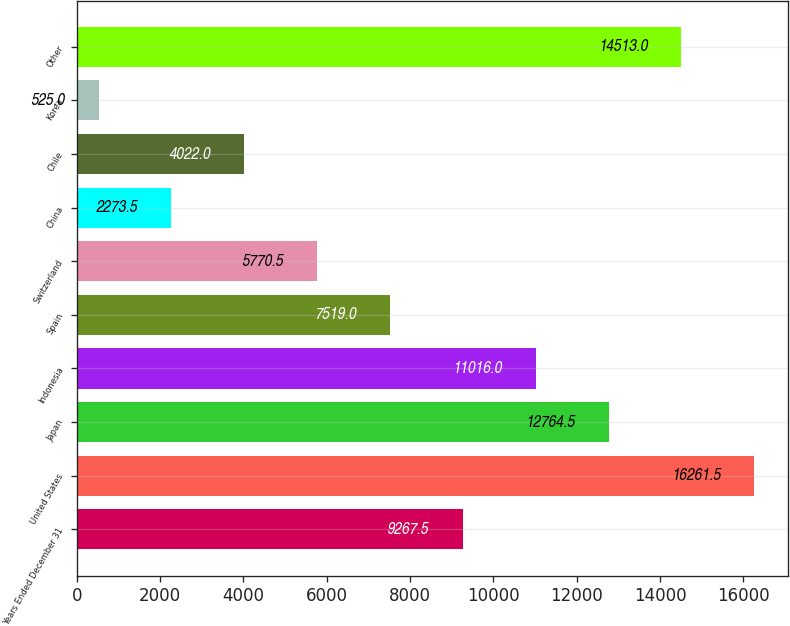Convert chart. <chart><loc_0><loc_0><loc_500><loc_500><bar_chart><fcel>Years Ended December 31<fcel>United States<fcel>Japan<fcel>Indonesia<fcel>Spain<fcel>Switzerland<fcel>China<fcel>Chile<fcel>Korea<fcel>Other<nl><fcel>9267.5<fcel>16261.5<fcel>12764.5<fcel>11016<fcel>7519<fcel>5770.5<fcel>2273.5<fcel>4022<fcel>525<fcel>14513<nl></chart> 